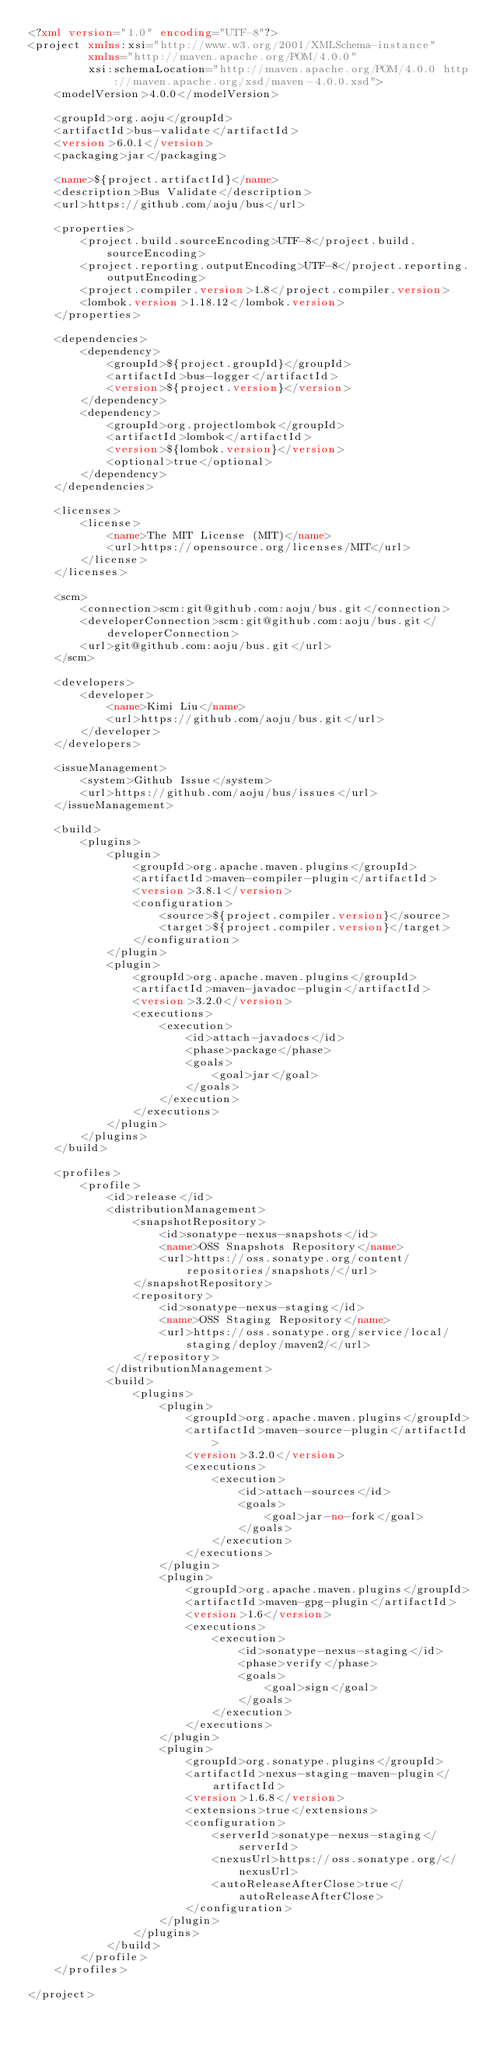<code> <loc_0><loc_0><loc_500><loc_500><_XML_><?xml version="1.0" encoding="UTF-8"?>
<project xmlns:xsi="http://www.w3.org/2001/XMLSchema-instance"
         xmlns="http://maven.apache.org/POM/4.0.0"
         xsi:schemaLocation="http://maven.apache.org/POM/4.0.0 http://maven.apache.org/xsd/maven-4.0.0.xsd">
    <modelVersion>4.0.0</modelVersion>

    <groupId>org.aoju</groupId>
    <artifactId>bus-validate</artifactId>
    <version>6.0.1</version>
    <packaging>jar</packaging>

    <name>${project.artifactId}</name>
    <description>Bus Validate</description>
    <url>https://github.com/aoju/bus</url>

    <properties>
        <project.build.sourceEncoding>UTF-8</project.build.sourceEncoding>
        <project.reporting.outputEncoding>UTF-8</project.reporting.outputEncoding>
        <project.compiler.version>1.8</project.compiler.version>
        <lombok.version>1.18.12</lombok.version>
    </properties>

    <dependencies>
        <dependency>
            <groupId>${project.groupId}</groupId>
            <artifactId>bus-logger</artifactId>
            <version>${project.version}</version>
        </dependency>
        <dependency>
            <groupId>org.projectlombok</groupId>
            <artifactId>lombok</artifactId>
            <version>${lombok.version}</version>
            <optional>true</optional>
        </dependency>
    </dependencies>

    <licenses>
        <license>
            <name>The MIT License (MIT)</name>
            <url>https://opensource.org/licenses/MIT</url>
        </license>
    </licenses>

    <scm>
        <connection>scm:git@github.com:aoju/bus.git</connection>
        <developerConnection>scm:git@github.com:aoju/bus.git</developerConnection>
        <url>git@github.com:aoju/bus.git</url>
    </scm>

    <developers>
        <developer>
            <name>Kimi Liu</name>
            <url>https://github.com/aoju/bus.git</url>
        </developer>
    </developers>

    <issueManagement>
        <system>Github Issue</system>
        <url>https://github.com/aoju/bus/issues</url>
    </issueManagement>

    <build>
        <plugins>
            <plugin>
                <groupId>org.apache.maven.plugins</groupId>
                <artifactId>maven-compiler-plugin</artifactId>
                <version>3.8.1</version>
                <configuration>
                    <source>${project.compiler.version}</source>
                    <target>${project.compiler.version}</target>
                </configuration>
            </plugin>
            <plugin>
                <groupId>org.apache.maven.plugins</groupId>
                <artifactId>maven-javadoc-plugin</artifactId>
                <version>3.2.0</version>
                <executions>
                    <execution>
                        <id>attach-javadocs</id>
                        <phase>package</phase>
                        <goals>
                            <goal>jar</goal>
                        </goals>
                    </execution>
                </executions>
            </plugin>
        </plugins>
    </build>

    <profiles>
        <profile>
            <id>release</id>
            <distributionManagement>
                <snapshotRepository>
                    <id>sonatype-nexus-snapshots</id>
                    <name>OSS Snapshots Repository</name>
                    <url>https://oss.sonatype.org/content/repositories/snapshots/</url>
                </snapshotRepository>
                <repository>
                    <id>sonatype-nexus-staging</id>
                    <name>OSS Staging Repository</name>
                    <url>https://oss.sonatype.org/service/local/staging/deploy/maven2/</url>
                </repository>
            </distributionManagement>
            <build>
                <plugins>
                    <plugin>
                        <groupId>org.apache.maven.plugins</groupId>
                        <artifactId>maven-source-plugin</artifactId>
                        <version>3.2.0</version>
                        <executions>
                            <execution>
                                <id>attach-sources</id>
                                <goals>
                                    <goal>jar-no-fork</goal>
                                </goals>
                            </execution>
                        </executions>
                    </plugin>
                    <plugin>
                        <groupId>org.apache.maven.plugins</groupId>
                        <artifactId>maven-gpg-plugin</artifactId>
                        <version>1.6</version>
                        <executions>
                            <execution>
                                <id>sonatype-nexus-staging</id>
                                <phase>verify</phase>
                                <goals>
                                    <goal>sign</goal>
                                </goals>
                            </execution>
                        </executions>
                    </plugin>
                    <plugin>
                        <groupId>org.sonatype.plugins</groupId>
                        <artifactId>nexus-staging-maven-plugin</artifactId>
                        <version>1.6.8</version>
                        <extensions>true</extensions>
                        <configuration>
                            <serverId>sonatype-nexus-staging</serverId>
                            <nexusUrl>https://oss.sonatype.org/</nexusUrl>
                            <autoReleaseAfterClose>true</autoReleaseAfterClose>
                        </configuration>
                    </plugin>
                </plugins>
            </build>
        </profile>
    </profiles>

</project>
</code> 